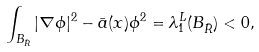Convert formula to latex. <formula><loc_0><loc_0><loc_500><loc_500>\int _ { B _ { \bar { R } } } | \nabla \phi | ^ { 2 } - \bar { a } ( x ) \phi ^ { 2 } = \lambda _ { 1 } ^ { \bar { L } } ( B _ { \bar { R } } ) < 0 ,</formula> 